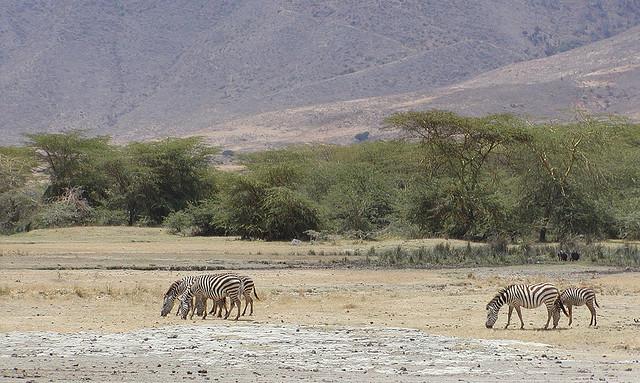How many zebras?
Quick response, please. 4. What happened to the vegetation?
Be succinct. Died. Do these animals know each other?
Write a very short answer. Yes. What natural structure is behind the trees?
Be succinct. Mountain. Where are the zebras at?
Write a very short answer. Africa. Is there lots of grass to eat?
Be succinct. No. 